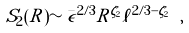<formula> <loc_0><loc_0><loc_500><loc_500>S _ { 2 } ( R ) \sim \bar { \epsilon } ^ { 2 / 3 } R ^ { \zeta _ { 2 } } \ell ^ { 2 / 3 - \zeta _ { 2 } } \ ,</formula> 